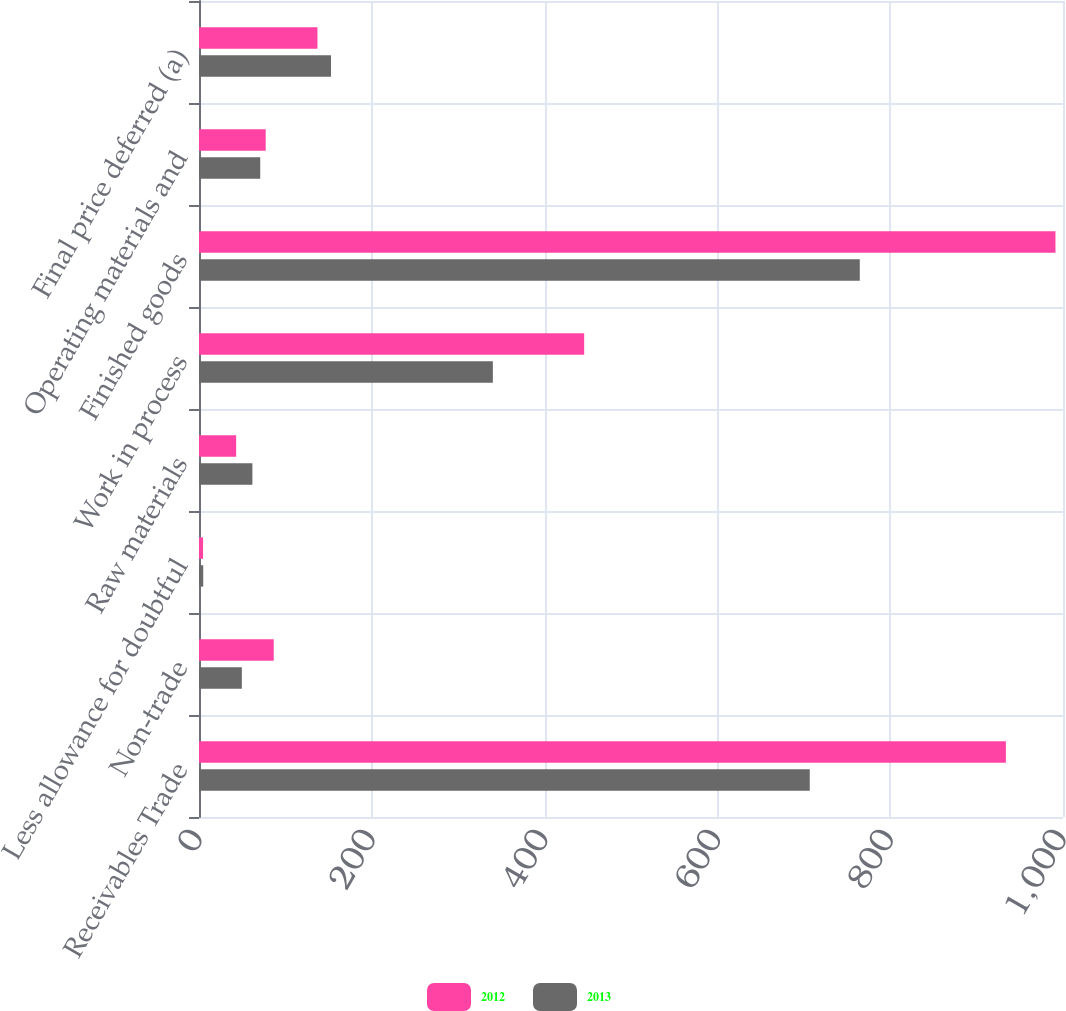<chart> <loc_0><loc_0><loc_500><loc_500><stacked_bar_chart><ecel><fcel>Receivables Trade<fcel>Non-trade<fcel>Less allowance for doubtful<fcel>Raw materials<fcel>Work in process<fcel>Finished goods<fcel>Operating materials and<fcel>Final price deferred (a)<nl><fcel>2012<fcel>933.9<fcel>86.5<fcel>4.7<fcel>43<fcel>445.8<fcel>991.3<fcel>77.2<fcel>137.1<nl><fcel>2013<fcel>706.9<fcel>49.6<fcel>4.9<fcel>61.8<fcel>340.1<fcel>764.8<fcel>70.9<fcel>152.8<nl></chart> 